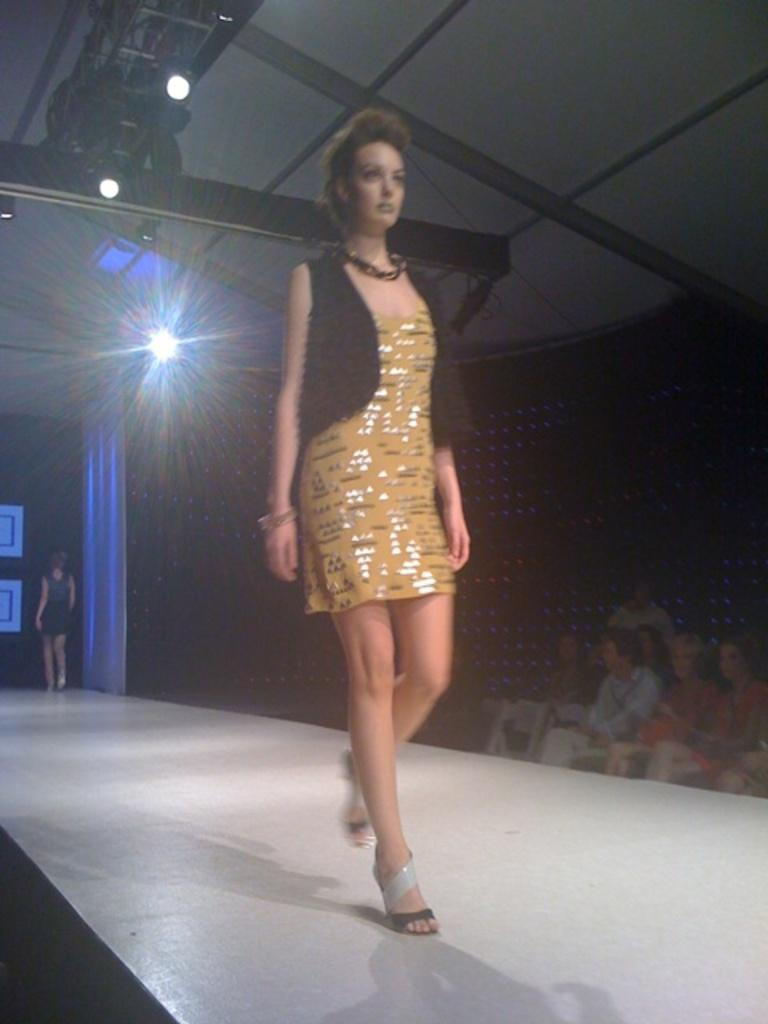Who is the main subject in the image? There is a woman in the image. What is the woman doing in the image? The woman is walking on a stage. What can be seen in the background of the image? There are lights and people visible in the background of the image. Can you see any deer running across the stage in the image? No, there are no deer or running depicted in the image. 